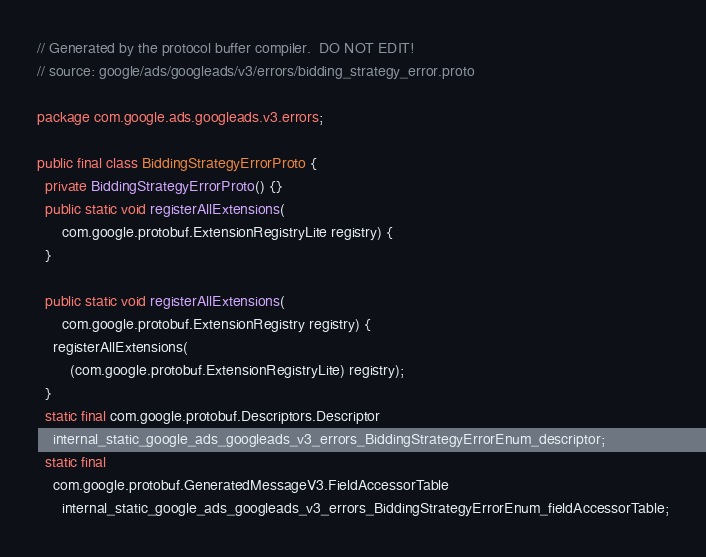Convert code to text. <code><loc_0><loc_0><loc_500><loc_500><_Java_>// Generated by the protocol buffer compiler.  DO NOT EDIT!
// source: google/ads/googleads/v3/errors/bidding_strategy_error.proto

package com.google.ads.googleads.v3.errors;

public final class BiddingStrategyErrorProto {
  private BiddingStrategyErrorProto() {}
  public static void registerAllExtensions(
      com.google.protobuf.ExtensionRegistryLite registry) {
  }

  public static void registerAllExtensions(
      com.google.protobuf.ExtensionRegistry registry) {
    registerAllExtensions(
        (com.google.protobuf.ExtensionRegistryLite) registry);
  }
  static final com.google.protobuf.Descriptors.Descriptor
    internal_static_google_ads_googleads_v3_errors_BiddingStrategyErrorEnum_descriptor;
  static final 
    com.google.protobuf.GeneratedMessageV3.FieldAccessorTable
      internal_static_google_ads_googleads_v3_errors_BiddingStrategyErrorEnum_fieldAccessorTable;
</code> 